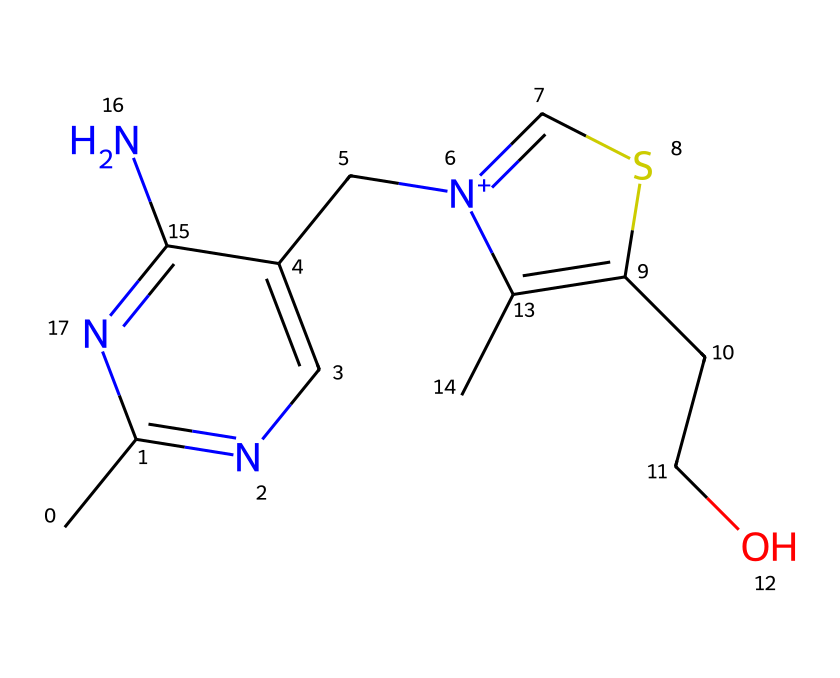What is the molecular formula of thiamine? To determine the molecular formula, we count the number of each type of atom present in the SMILES representation. The breakdown shows 12 carbon (C), 17 hydrogen (H), 4 nitrogen (N), and 2 sulfur (S) atoms. Therefore, the molecular formula is C12H17N4S.
Answer: C12H17N4S How many sulfur atoms are in thiamine? By analyzing the SMILES structure, we can identify the number of sulfur atoms specifically. The count shows there are 2 sulfur (S) atoms in the chemical structure of thiamine.
Answer: 2 What type of bond connects the carbon atoms to other atoms in thiamine? The structural representation indicates that carbon atoms form single and some double bonds with other atoms. Typically, carbon in organic compounds like thiamine primarily forms single bonds with hydrogen and other elements in a tetrahedral geometry.
Answer: single and double bonds Which functional group in thiamine is crucial for its biological activity? In thiamine, the thiazole ring containing nitrogen and sulfur plays a key role in its biological function, being integral in the coenzyme's activity for metabolism, specifically in carbohydrate metabolism.
Answer: thiazole ring What are the two distinct sections seen in the thiamine molecule? Thiamine can be divided into two main parts: the pyrimidine ring and the thiazole ring. This division is crucial as each part contributes to the overall activity of the vitamin.
Answer: pyrimidine ring and thiazole ring How many rings are present in the structure of thiamine? By identifying the cyclic structures in the SMILES representation, it's clear that there are two rings: a pyrimidine ring and a thiazole ring that contribute to the structure of thiamine.
Answer: 2 